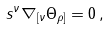Convert formula to latex. <formula><loc_0><loc_0><loc_500><loc_500>s ^ { \nu } \nabla _ { [ \nu } \Theta _ { \rho ] } = 0 \, ,</formula> 